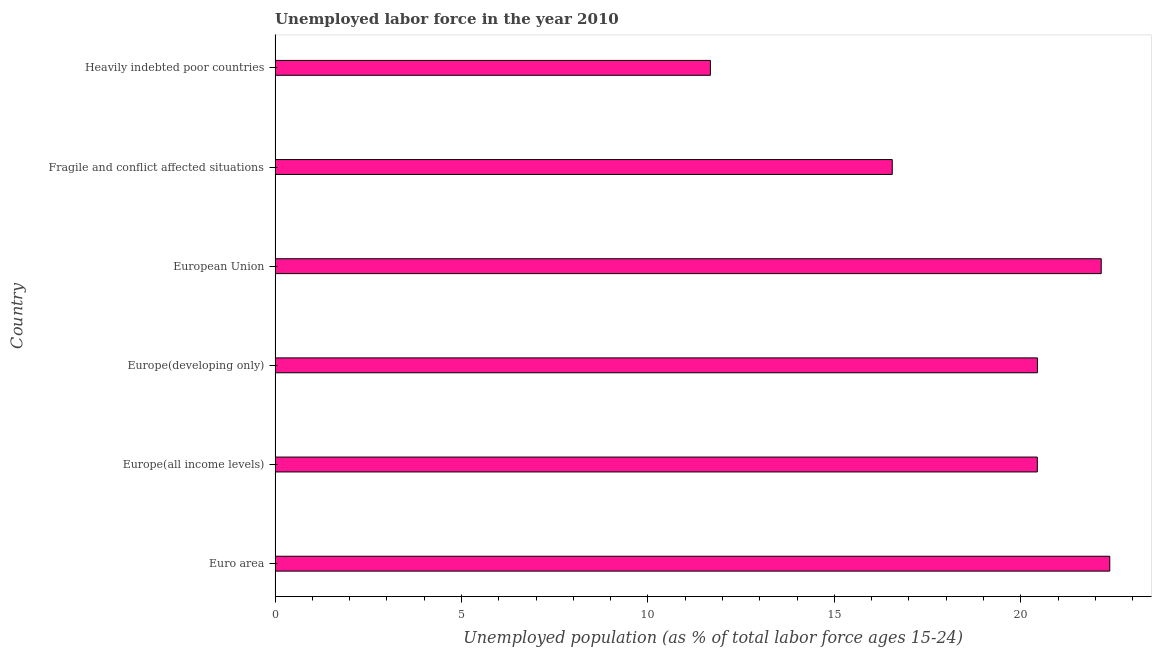Does the graph contain any zero values?
Offer a terse response. No. What is the title of the graph?
Give a very brief answer. Unemployed labor force in the year 2010. What is the label or title of the X-axis?
Make the answer very short. Unemployed population (as % of total labor force ages 15-24). What is the label or title of the Y-axis?
Your answer should be very brief. Country. What is the total unemployed youth population in Euro area?
Your response must be concise. 22.39. Across all countries, what is the maximum total unemployed youth population?
Your answer should be very brief. 22.39. Across all countries, what is the minimum total unemployed youth population?
Offer a very short reply. 11.68. In which country was the total unemployed youth population minimum?
Your answer should be very brief. Heavily indebted poor countries. What is the sum of the total unemployed youth population?
Your response must be concise. 113.67. What is the difference between the total unemployed youth population in Euro area and Heavily indebted poor countries?
Provide a succinct answer. 10.71. What is the average total unemployed youth population per country?
Offer a very short reply. 18.95. What is the median total unemployed youth population?
Your response must be concise. 20.45. What is the ratio of the total unemployed youth population in Euro area to that in Europe(developing only)?
Keep it short and to the point. 1.09. What is the difference between the highest and the second highest total unemployed youth population?
Your answer should be compact. 0.23. Is the sum of the total unemployed youth population in Euro area and Europe(developing only) greater than the maximum total unemployed youth population across all countries?
Offer a very short reply. Yes. What is the difference between the highest and the lowest total unemployed youth population?
Your answer should be compact. 10.71. In how many countries, is the total unemployed youth population greater than the average total unemployed youth population taken over all countries?
Your answer should be compact. 4. What is the difference between two consecutive major ticks on the X-axis?
Your answer should be compact. 5. Are the values on the major ticks of X-axis written in scientific E-notation?
Give a very brief answer. No. What is the Unemployed population (as % of total labor force ages 15-24) in Euro area?
Give a very brief answer. 22.39. What is the Unemployed population (as % of total labor force ages 15-24) of Europe(all income levels)?
Offer a terse response. 20.44. What is the Unemployed population (as % of total labor force ages 15-24) in Europe(developing only)?
Make the answer very short. 20.45. What is the Unemployed population (as % of total labor force ages 15-24) in European Union?
Keep it short and to the point. 22.16. What is the Unemployed population (as % of total labor force ages 15-24) of Fragile and conflict affected situations?
Your response must be concise. 16.55. What is the Unemployed population (as % of total labor force ages 15-24) in Heavily indebted poor countries?
Offer a terse response. 11.68. What is the difference between the Unemployed population (as % of total labor force ages 15-24) in Euro area and Europe(all income levels)?
Make the answer very short. 1.94. What is the difference between the Unemployed population (as % of total labor force ages 15-24) in Euro area and Europe(developing only)?
Provide a short and direct response. 1.94. What is the difference between the Unemployed population (as % of total labor force ages 15-24) in Euro area and European Union?
Provide a succinct answer. 0.23. What is the difference between the Unemployed population (as % of total labor force ages 15-24) in Euro area and Fragile and conflict affected situations?
Offer a terse response. 5.83. What is the difference between the Unemployed population (as % of total labor force ages 15-24) in Euro area and Heavily indebted poor countries?
Keep it short and to the point. 10.71. What is the difference between the Unemployed population (as % of total labor force ages 15-24) in Europe(all income levels) and Europe(developing only)?
Your answer should be compact. -0. What is the difference between the Unemployed population (as % of total labor force ages 15-24) in Europe(all income levels) and European Union?
Make the answer very short. -1.71. What is the difference between the Unemployed population (as % of total labor force ages 15-24) in Europe(all income levels) and Fragile and conflict affected situations?
Ensure brevity in your answer.  3.89. What is the difference between the Unemployed population (as % of total labor force ages 15-24) in Europe(all income levels) and Heavily indebted poor countries?
Provide a succinct answer. 8.77. What is the difference between the Unemployed population (as % of total labor force ages 15-24) in Europe(developing only) and European Union?
Ensure brevity in your answer.  -1.71. What is the difference between the Unemployed population (as % of total labor force ages 15-24) in Europe(developing only) and Fragile and conflict affected situations?
Offer a terse response. 3.89. What is the difference between the Unemployed population (as % of total labor force ages 15-24) in Europe(developing only) and Heavily indebted poor countries?
Your answer should be compact. 8.77. What is the difference between the Unemployed population (as % of total labor force ages 15-24) in European Union and Fragile and conflict affected situations?
Your answer should be compact. 5.61. What is the difference between the Unemployed population (as % of total labor force ages 15-24) in European Union and Heavily indebted poor countries?
Offer a terse response. 10.48. What is the difference between the Unemployed population (as % of total labor force ages 15-24) in Fragile and conflict affected situations and Heavily indebted poor countries?
Your answer should be very brief. 4.88. What is the ratio of the Unemployed population (as % of total labor force ages 15-24) in Euro area to that in Europe(all income levels)?
Provide a succinct answer. 1.09. What is the ratio of the Unemployed population (as % of total labor force ages 15-24) in Euro area to that in Europe(developing only)?
Keep it short and to the point. 1.09. What is the ratio of the Unemployed population (as % of total labor force ages 15-24) in Euro area to that in European Union?
Keep it short and to the point. 1.01. What is the ratio of the Unemployed population (as % of total labor force ages 15-24) in Euro area to that in Fragile and conflict affected situations?
Keep it short and to the point. 1.35. What is the ratio of the Unemployed population (as % of total labor force ages 15-24) in Euro area to that in Heavily indebted poor countries?
Provide a short and direct response. 1.92. What is the ratio of the Unemployed population (as % of total labor force ages 15-24) in Europe(all income levels) to that in European Union?
Your response must be concise. 0.92. What is the ratio of the Unemployed population (as % of total labor force ages 15-24) in Europe(all income levels) to that in Fragile and conflict affected situations?
Offer a terse response. 1.24. What is the ratio of the Unemployed population (as % of total labor force ages 15-24) in Europe(all income levels) to that in Heavily indebted poor countries?
Offer a very short reply. 1.75. What is the ratio of the Unemployed population (as % of total labor force ages 15-24) in Europe(developing only) to that in European Union?
Provide a short and direct response. 0.92. What is the ratio of the Unemployed population (as % of total labor force ages 15-24) in Europe(developing only) to that in Fragile and conflict affected situations?
Provide a succinct answer. 1.24. What is the ratio of the Unemployed population (as % of total labor force ages 15-24) in Europe(developing only) to that in Heavily indebted poor countries?
Ensure brevity in your answer.  1.75. What is the ratio of the Unemployed population (as % of total labor force ages 15-24) in European Union to that in Fragile and conflict affected situations?
Provide a succinct answer. 1.34. What is the ratio of the Unemployed population (as % of total labor force ages 15-24) in European Union to that in Heavily indebted poor countries?
Make the answer very short. 1.9. What is the ratio of the Unemployed population (as % of total labor force ages 15-24) in Fragile and conflict affected situations to that in Heavily indebted poor countries?
Ensure brevity in your answer.  1.42. 